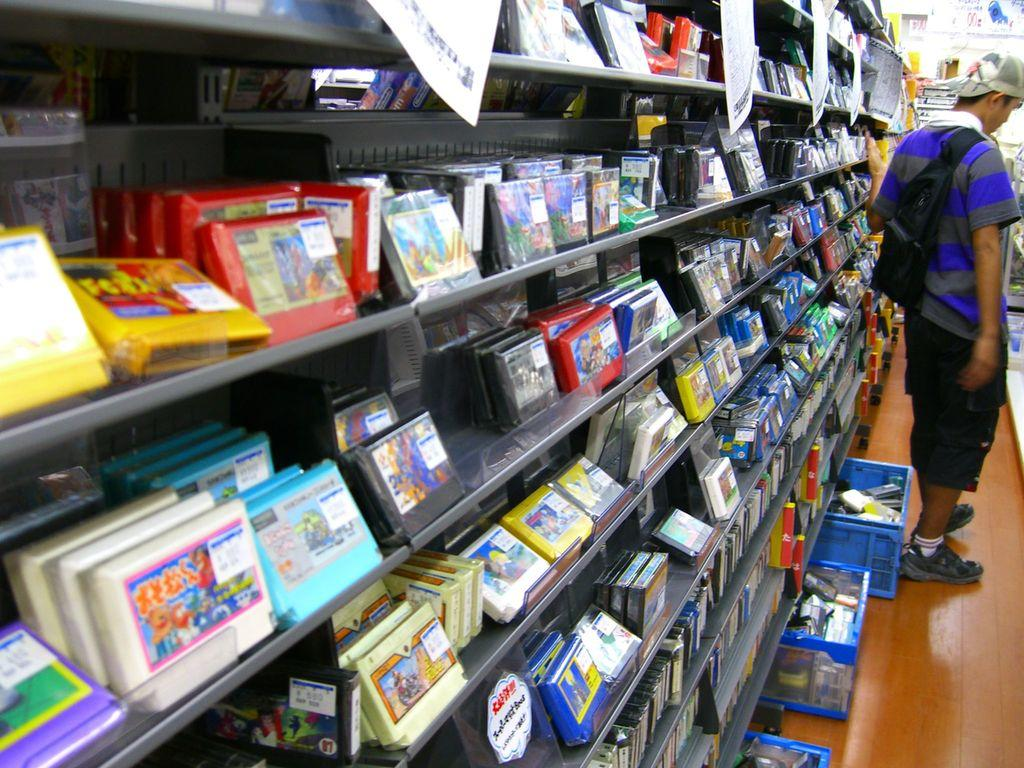What is the person in the image doing? A: The person is standing on the floor. What objects can be seen in the image besides the person? There are baskets, gaming accessories, and posters are visible in the image. Where are the gaming accessories located? The gaming accessories are on a rack. What type of ray can be seen swimming in the image? There is no ray present in the image; it features a person standing on the floor, baskets, gaming accessories, and posters. What kind of noise can be heard coming from the image? There is no sound or noise present in the image, as it is a still photograph. 